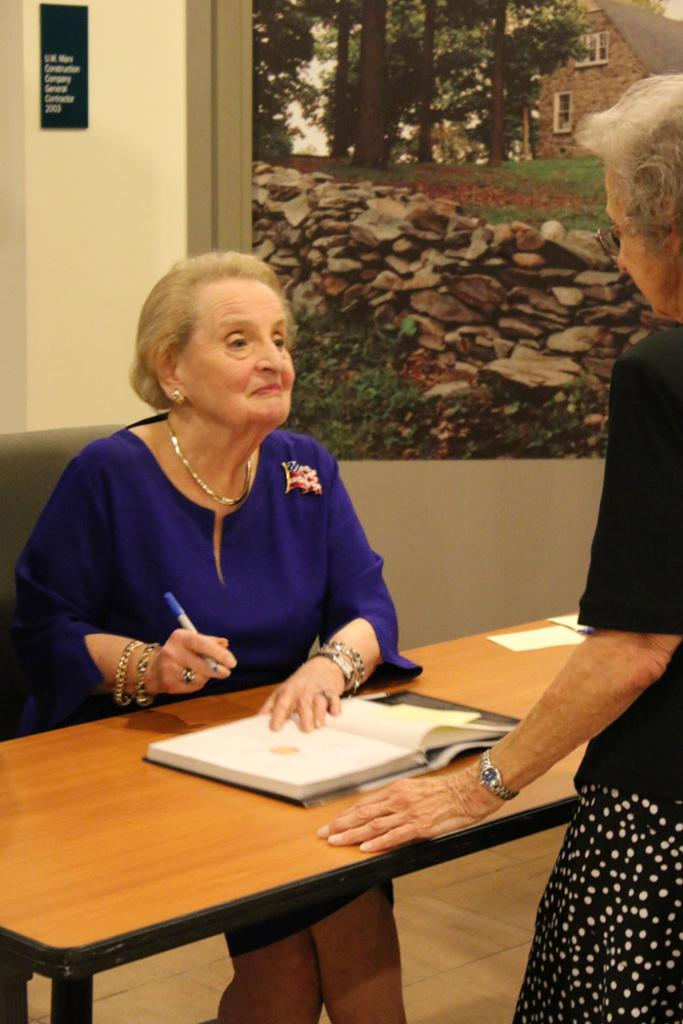How many people are in the image? There are two people in the image. What is in front of the people? There is a table in front of the people. What items are on the table? There is a book and a pen on the table. What type of blade is being used by one of the people in the image? There is no blade present in the image. Is there a car visible in the image? No, there is no car visible in the image. 